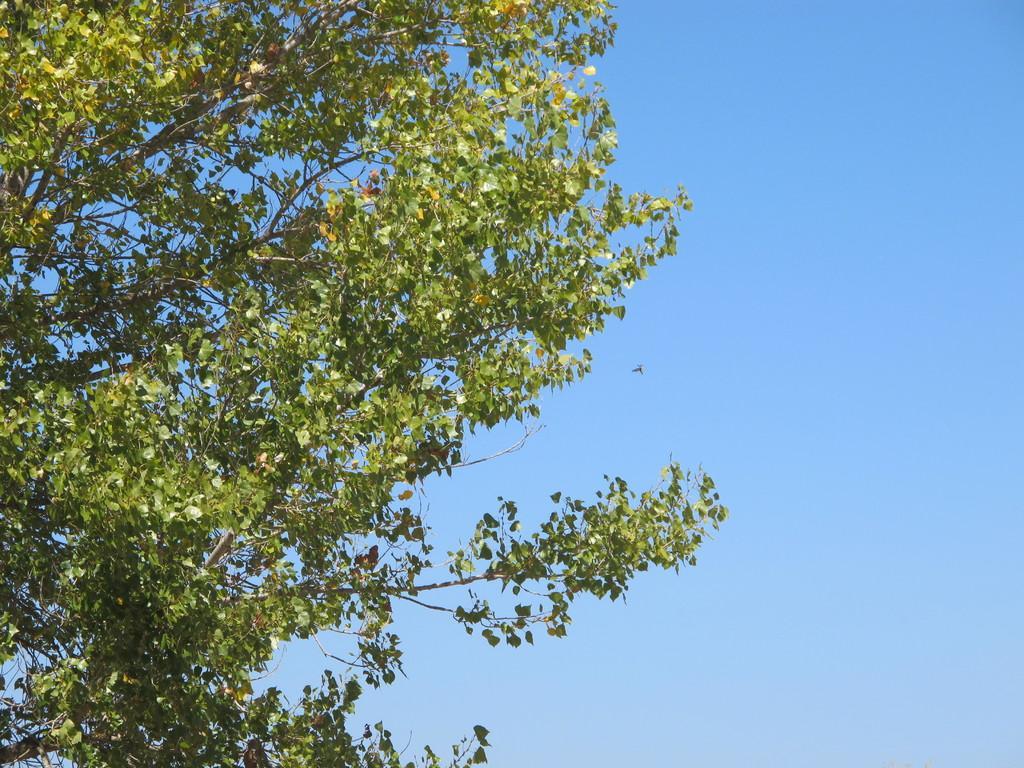Can you describe this image briefly? This is the picture of a tree with green colored leaves and in the background, we can see the sky. 